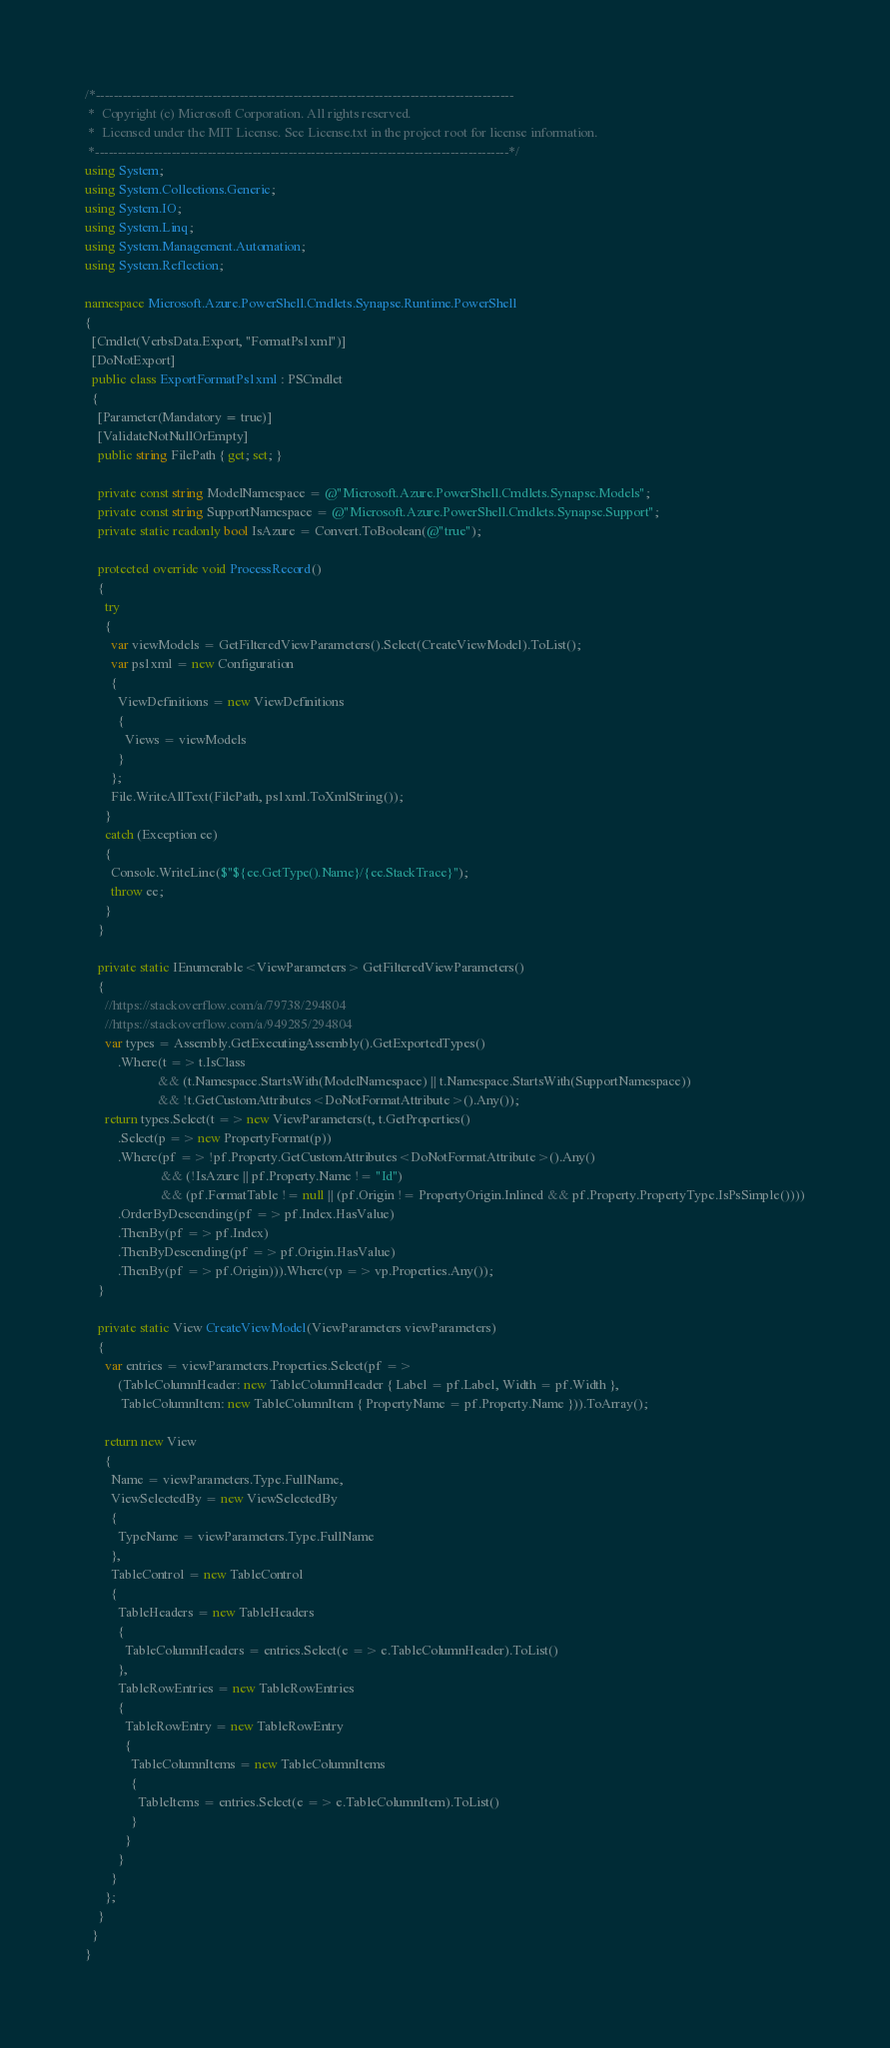<code> <loc_0><loc_0><loc_500><loc_500><_C#_>/*---------------------------------------------------------------------------------------------
 *  Copyright (c) Microsoft Corporation. All rights reserved.
 *  Licensed under the MIT License. See License.txt in the project root for license information.
 *--------------------------------------------------------------------------------------------*/
using System;
using System.Collections.Generic;
using System.IO;
using System.Linq;
using System.Management.Automation;
using System.Reflection;

namespace Microsoft.Azure.PowerShell.Cmdlets.Synapse.Runtime.PowerShell
{
  [Cmdlet(VerbsData.Export, "FormatPs1xml")]
  [DoNotExport]
  public class ExportFormatPs1xml : PSCmdlet
  {
    [Parameter(Mandatory = true)]
    [ValidateNotNullOrEmpty]
    public string FilePath { get; set; }

    private const string ModelNamespace = @"Microsoft.Azure.PowerShell.Cmdlets.Synapse.Models";
    private const string SupportNamespace = @"Microsoft.Azure.PowerShell.Cmdlets.Synapse.Support";
    private static readonly bool IsAzure = Convert.ToBoolean(@"true");

    protected override void ProcessRecord()
    {
      try
      {
        var viewModels = GetFilteredViewParameters().Select(CreateViewModel).ToList();
        var ps1xml = new Configuration
        {
          ViewDefinitions = new ViewDefinitions
          {
            Views = viewModels
          }
        };
        File.WriteAllText(FilePath, ps1xml.ToXmlString());
      }
      catch (Exception ee)
      {
        Console.WriteLine($"${ee.GetType().Name}/{ee.StackTrace}");
        throw ee;
      }
    }

    private static IEnumerable<ViewParameters> GetFilteredViewParameters()
    {
      //https://stackoverflow.com/a/79738/294804
      //https://stackoverflow.com/a/949285/294804
      var types = Assembly.GetExecutingAssembly().GetExportedTypes()
          .Where(t => t.IsClass
                      && (t.Namespace.StartsWith(ModelNamespace) || t.Namespace.StartsWith(SupportNamespace))
                      && !t.GetCustomAttributes<DoNotFormatAttribute>().Any());
      return types.Select(t => new ViewParameters(t, t.GetProperties()
          .Select(p => new PropertyFormat(p))
          .Where(pf => !pf.Property.GetCustomAttributes<DoNotFormatAttribute>().Any()
                       && (!IsAzure || pf.Property.Name != "Id")
                       && (pf.FormatTable != null || (pf.Origin != PropertyOrigin.Inlined && pf.Property.PropertyType.IsPsSimple())))
          .OrderByDescending(pf => pf.Index.HasValue)
          .ThenBy(pf => pf.Index)
          .ThenByDescending(pf => pf.Origin.HasValue)
          .ThenBy(pf => pf.Origin))).Where(vp => vp.Properties.Any());
    }

    private static View CreateViewModel(ViewParameters viewParameters)
    {
      var entries = viewParameters.Properties.Select(pf =>
          (TableColumnHeader: new TableColumnHeader { Label = pf.Label, Width = pf.Width },
           TableColumnItem: new TableColumnItem { PropertyName = pf.Property.Name })).ToArray();

      return new View
      {
        Name = viewParameters.Type.FullName,
        ViewSelectedBy = new ViewSelectedBy
        {
          TypeName = viewParameters.Type.FullName
        },
        TableControl = new TableControl
        {
          TableHeaders = new TableHeaders
          {
            TableColumnHeaders = entries.Select(e => e.TableColumnHeader).ToList()
          },
          TableRowEntries = new TableRowEntries
          {
            TableRowEntry = new TableRowEntry
            {
              TableColumnItems = new TableColumnItems
              {
                TableItems = entries.Select(e => e.TableColumnItem).ToList()
              }
            }
          }
        }
      };
    }
  }
}
</code> 